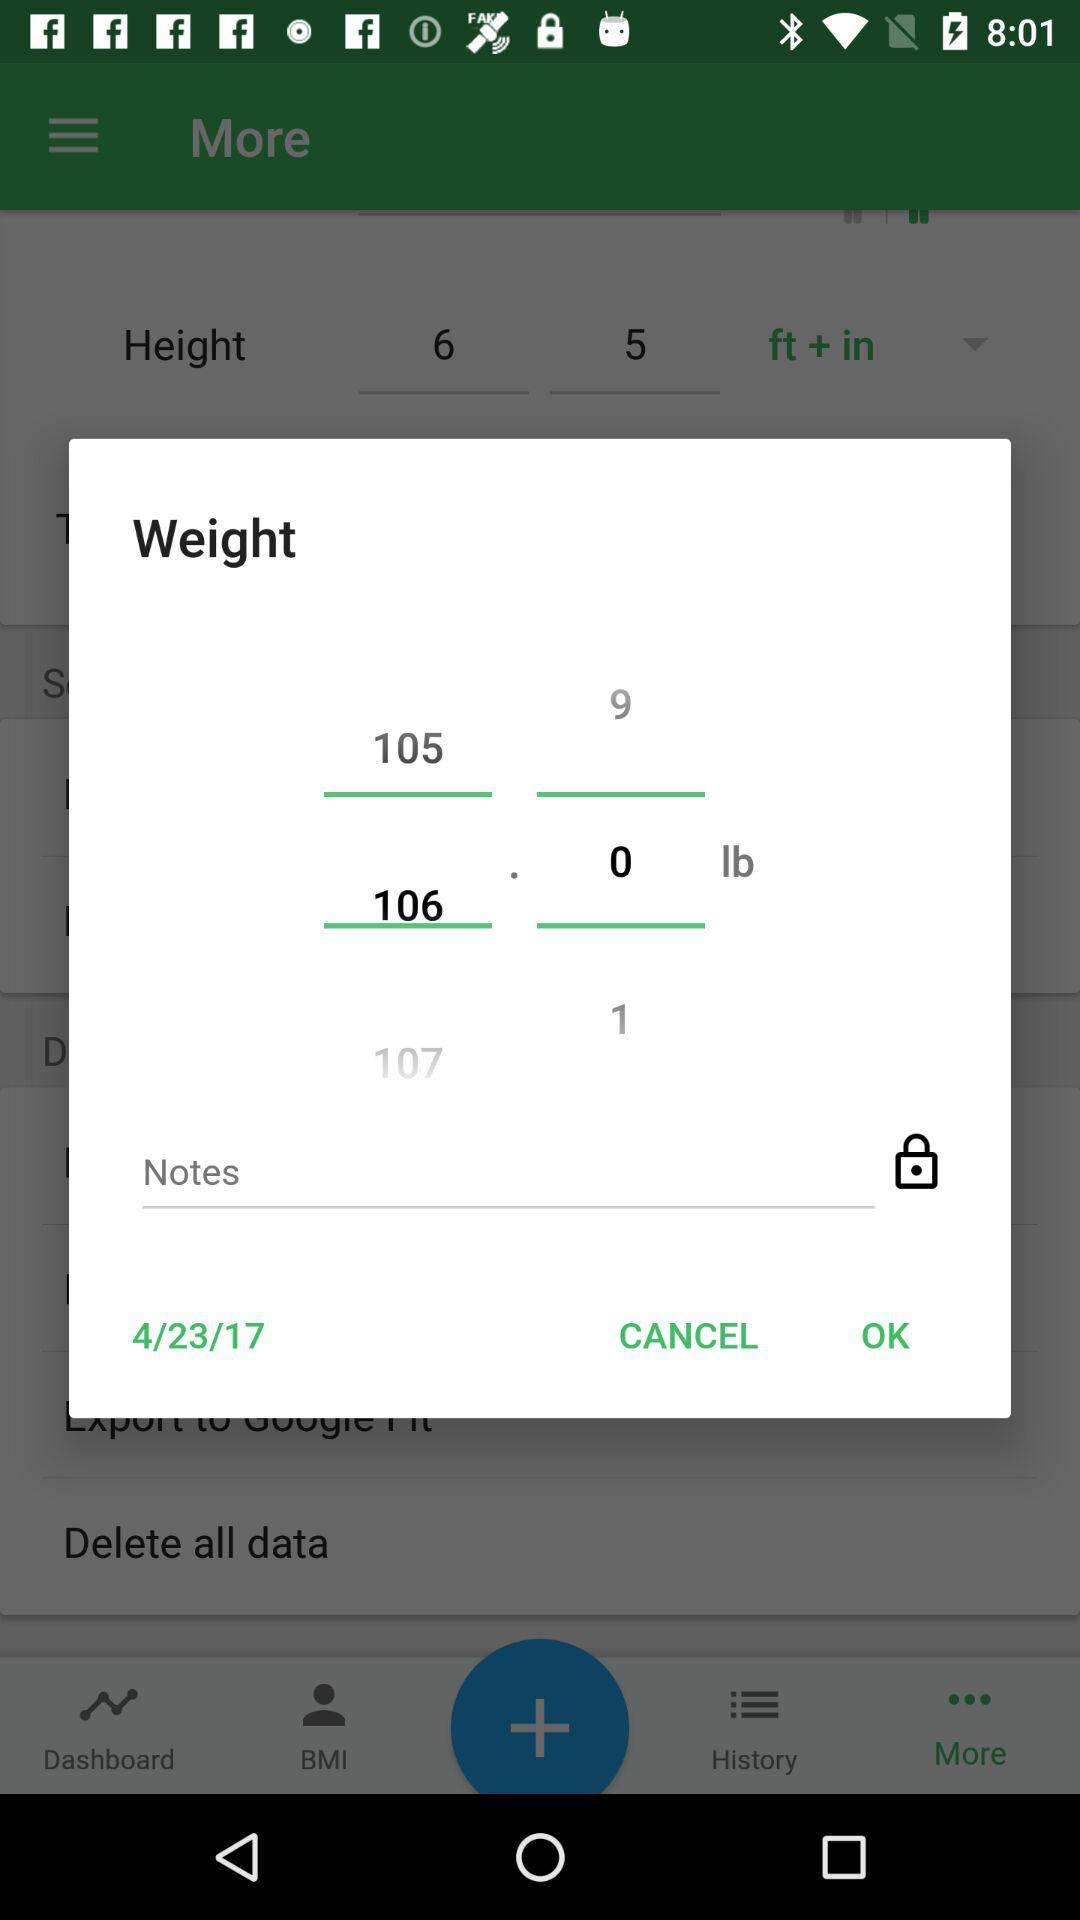What is the difference between the weight of the 107th item and the weight of the 106th item?
Answer the question using a single word or phrase. 1 